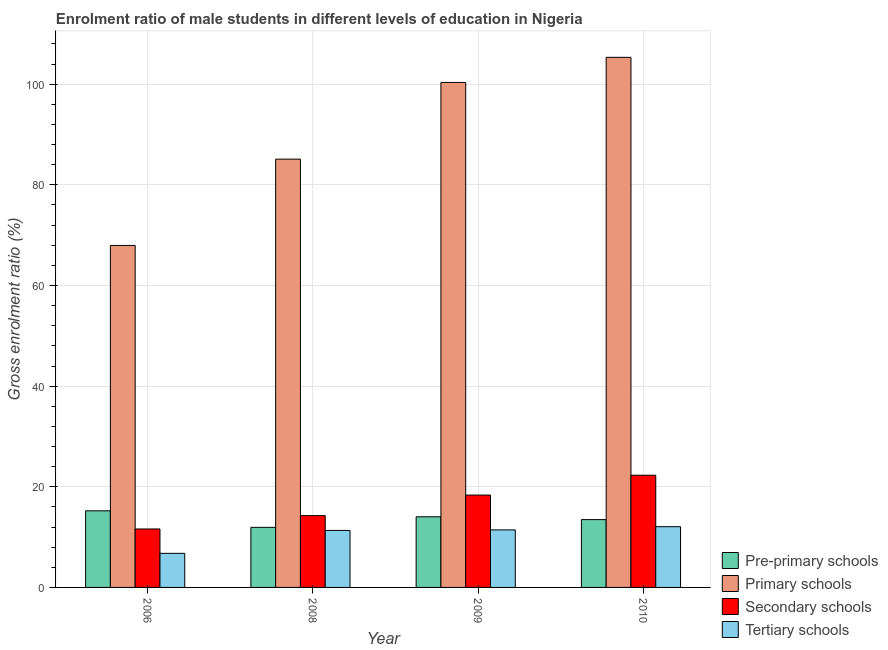How many different coloured bars are there?
Your response must be concise. 4. Are the number of bars on each tick of the X-axis equal?
Make the answer very short. Yes. How many bars are there on the 1st tick from the left?
Offer a terse response. 4. What is the gross enrolment ratio(female) in secondary schools in 2006?
Give a very brief answer. 11.61. Across all years, what is the maximum gross enrolment ratio(female) in primary schools?
Provide a short and direct response. 105.34. Across all years, what is the minimum gross enrolment ratio(female) in primary schools?
Keep it short and to the point. 67.96. In which year was the gross enrolment ratio(female) in tertiary schools minimum?
Give a very brief answer. 2006. What is the total gross enrolment ratio(female) in primary schools in the graph?
Give a very brief answer. 358.75. What is the difference between the gross enrolment ratio(female) in primary schools in 2008 and that in 2009?
Your response must be concise. -15.24. What is the difference between the gross enrolment ratio(female) in secondary schools in 2009 and the gross enrolment ratio(female) in tertiary schools in 2010?
Make the answer very short. -3.94. What is the average gross enrolment ratio(female) in primary schools per year?
Give a very brief answer. 89.69. In how many years, is the gross enrolment ratio(female) in pre-primary schools greater than 56 %?
Make the answer very short. 0. What is the ratio of the gross enrolment ratio(female) in tertiary schools in 2006 to that in 2008?
Provide a succinct answer. 0.6. Is the gross enrolment ratio(female) in tertiary schools in 2008 less than that in 2009?
Provide a short and direct response. Yes. What is the difference between the highest and the second highest gross enrolment ratio(female) in secondary schools?
Your answer should be compact. 3.94. What is the difference between the highest and the lowest gross enrolment ratio(female) in pre-primary schools?
Make the answer very short. 3.29. Is the sum of the gross enrolment ratio(female) in primary schools in 2009 and 2010 greater than the maximum gross enrolment ratio(female) in secondary schools across all years?
Offer a very short reply. Yes. Is it the case that in every year, the sum of the gross enrolment ratio(female) in pre-primary schools and gross enrolment ratio(female) in primary schools is greater than the sum of gross enrolment ratio(female) in secondary schools and gross enrolment ratio(female) in tertiary schools?
Provide a succinct answer. No. What does the 4th bar from the left in 2006 represents?
Provide a succinct answer. Tertiary schools. What does the 2nd bar from the right in 2010 represents?
Ensure brevity in your answer.  Secondary schools. Is it the case that in every year, the sum of the gross enrolment ratio(female) in pre-primary schools and gross enrolment ratio(female) in primary schools is greater than the gross enrolment ratio(female) in secondary schools?
Provide a short and direct response. Yes. Are all the bars in the graph horizontal?
Provide a succinct answer. No. Are the values on the major ticks of Y-axis written in scientific E-notation?
Your response must be concise. No. Does the graph contain any zero values?
Give a very brief answer. No. Where does the legend appear in the graph?
Give a very brief answer. Bottom right. How are the legend labels stacked?
Give a very brief answer. Vertical. What is the title of the graph?
Offer a terse response. Enrolment ratio of male students in different levels of education in Nigeria. Does "Natural Gas" appear as one of the legend labels in the graph?
Offer a very short reply. No. What is the label or title of the X-axis?
Provide a succinct answer. Year. What is the Gross enrolment ratio (%) of Pre-primary schools in 2006?
Make the answer very short. 15.23. What is the Gross enrolment ratio (%) of Primary schools in 2006?
Provide a short and direct response. 67.96. What is the Gross enrolment ratio (%) of Secondary schools in 2006?
Your answer should be very brief. 11.61. What is the Gross enrolment ratio (%) of Tertiary schools in 2006?
Keep it short and to the point. 6.78. What is the Gross enrolment ratio (%) of Pre-primary schools in 2008?
Make the answer very short. 11.94. What is the Gross enrolment ratio (%) in Primary schools in 2008?
Offer a very short reply. 85.11. What is the Gross enrolment ratio (%) in Secondary schools in 2008?
Ensure brevity in your answer.  14.27. What is the Gross enrolment ratio (%) of Tertiary schools in 2008?
Keep it short and to the point. 11.32. What is the Gross enrolment ratio (%) in Pre-primary schools in 2009?
Keep it short and to the point. 14.04. What is the Gross enrolment ratio (%) in Primary schools in 2009?
Your response must be concise. 100.35. What is the Gross enrolment ratio (%) of Secondary schools in 2009?
Your answer should be compact. 18.35. What is the Gross enrolment ratio (%) in Tertiary schools in 2009?
Offer a very short reply. 11.43. What is the Gross enrolment ratio (%) of Pre-primary schools in 2010?
Keep it short and to the point. 13.48. What is the Gross enrolment ratio (%) of Primary schools in 2010?
Give a very brief answer. 105.34. What is the Gross enrolment ratio (%) of Secondary schools in 2010?
Your response must be concise. 22.3. What is the Gross enrolment ratio (%) in Tertiary schools in 2010?
Provide a succinct answer. 12.07. Across all years, what is the maximum Gross enrolment ratio (%) of Pre-primary schools?
Offer a very short reply. 15.23. Across all years, what is the maximum Gross enrolment ratio (%) of Primary schools?
Offer a very short reply. 105.34. Across all years, what is the maximum Gross enrolment ratio (%) in Secondary schools?
Your answer should be compact. 22.3. Across all years, what is the maximum Gross enrolment ratio (%) in Tertiary schools?
Make the answer very short. 12.07. Across all years, what is the minimum Gross enrolment ratio (%) in Pre-primary schools?
Offer a terse response. 11.94. Across all years, what is the minimum Gross enrolment ratio (%) of Primary schools?
Your response must be concise. 67.96. Across all years, what is the minimum Gross enrolment ratio (%) in Secondary schools?
Give a very brief answer. 11.61. Across all years, what is the minimum Gross enrolment ratio (%) in Tertiary schools?
Give a very brief answer. 6.78. What is the total Gross enrolment ratio (%) in Pre-primary schools in the graph?
Make the answer very short. 54.68. What is the total Gross enrolment ratio (%) of Primary schools in the graph?
Offer a very short reply. 358.75. What is the total Gross enrolment ratio (%) of Secondary schools in the graph?
Give a very brief answer. 66.53. What is the total Gross enrolment ratio (%) of Tertiary schools in the graph?
Offer a terse response. 41.6. What is the difference between the Gross enrolment ratio (%) in Pre-primary schools in 2006 and that in 2008?
Your answer should be compact. 3.29. What is the difference between the Gross enrolment ratio (%) in Primary schools in 2006 and that in 2008?
Ensure brevity in your answer.  -17.15. What is the difference between the Gross enrolment ratio (%) in Secondary schools in 2006 and that in 2008?
Keep it short and to the point. -2.65. What is the difference between the Gross enrolment ratio (%) of Tertiary schools in 2006 and that in 2008?
Make the answer very short. -4.55. What is the difference between the Gross enrolment ratio (%) of Pre-primary schools in 2006 and that in 2009?
Your response must be concise. 1.19. What is the difference between the Gross enrolment ratio (%) of Primary schools in 2006 and that in 2009?
Ensure brevity in your answer.  -32.39. What is the difference between the Gross enrolment ratio (%) in Secondary schools in 2006 and that in 2009?
Provide a short and direct response. -6.74. What is the difference between the Gross enrolment ratio (%) of Tertiary schools in 2006 and that in 2009?
Provide a succinct answer. -4.66. What is the difference between the Gross enrolment ratio (%) of Pre-primary schools in 2006 and that in 2010?
Your answer should be compact. 1.75. What is the difference between the Gross enrolment ratio (%) in Primary schools in 2006 and that in 2010?
Your answer should be very brief. -37.38. What is the difference between the Gross enrolment ratio (%) in Secondary schools in 2006 and that in 2010?
Your answer should be compact. -10.68. What is the difference between the Gross enrolment ratio (%) in Tertiary schools in 2006 and that in 2010?
Your answer should be very brief. -5.29. What is the difference between the Gross enrolment ratio (%) of Pre-primary schools in 2008 and that in 2009?
Keep it short and to the point. -2.1. What is the difference between the Gross enrolment ratio (%) in Primary schools in 2008 and that in 2009?
Offer a very short reply. -15.24. What is the difference between the Gross enrolment ratio (%) of Secondary schools in 2008 and that in 2009?
Offer a very short reply. -4.09. What is the difference between the Gross enrolment ratio (%) of Tertiary schools in 2008 and that in 2009?
Ensure brevity in your answer.  -0.11. What is the difference between the Gross enrolment ratio (%) of Pre-primary schools in 2008 and that in 2010?
Your answer should be compact. -1.54. What is the difference between the Gross enrolment ratio (%) of Primary schools in 2008 and that in 2010?
Keep it short and to the point. -20.23. What is the difference between the Gross enrolment ratio (%) in Secondary schools in 2008 and that in 2010?
Give a very brief answer. -8.03. What is the difference between the Gross enrolment ratio (%) of Tertiary schools in 2008 and that in 2010?
Your answer should be compact. -0.75. What is the difference between the Gross enrolment ratio (%) in Pre-primary schools in 2009 and that in 2010?
Provide a succinct answer. 0.56. What is the difference between the Gross enrolment ratio (%) of Primary schools in 2009 and that in 2010?
Keep it short and to the point. -4.99. What is the difference between the Gross enrolment ratio (%) of Secondary schools in 2009 and that in 2010?
Ensure brevity in your answer.  -3.94. What is the difference between the Gross enrolment ratio (%) in Tertiary schools in 2009 and that in 2010?
Offer a very short reply. -0.64. What is the difference between the Gross enrolment ratio (%) of Pre-primary schools in 2006 and the Gross enrolment ratio (%) of Primary schools in 2008?
Offer a terse response. -69.88. What is the difference between the Gross enrolment ratio (%) of Pre-primary schools in 2006 and the Gross enrolment ratio (%) of Secondary schools in 2008?
Provide a short and direct response. 0.96. What is the difference between the Gross enrolment ratio (%) in Pre-primary schools in 2006 and the Gross enrolment ratio (%) in Tertiary schools in 2008?
Your response must be concise. 3.9. What is the difference between the Gross enrolment ratio (%) in Primary schools in 2006 and the Gross enrolment ratio (%) in Secondary schools in 2008?
Your answer should be very brief. 53.69. What is the difference between the Gross enrolment ratio (%) of Primary schools in 2006 and the Gross enrolment ratio (%) of Tertiary schools in 2008?
Your response must be concise. 56.64. What is the difference between the Gross enrolment ratio (%) of Secondary schools in 2006 and the Gross enrolment ratio (%) of Tertiary schools in 2008?
Keep it short and to the point. 0.29. What is the difference between the Gross enrolment ratio (%) of Pre-primary schools in 2006 and the Gross enrolment ratio (%) of Primary schools in 2009?
Your response must be concise. -85.12. What is the difference between the Gross enrolment ratio (%) of Pre-primary schools in 2006 and the Gross enrolment ratio (%) of Secondary schools in 2009?
Offer a terse response. -3.13. What is the difference between the Gross enrolment ratio (%) in Pre-primary schools in 2006 and the Gross enrolment ratio (%) in Tertiary schools in 2009?
Provide a short and direct response. 3.79. What is the difference between the Gross enrolment ratio (%) of Primary schools in 2006 and the Gross enrolment ratio (%) of Secondary schools in 2009?
Keep it short and to the point. 49.61. What is the difference between the Gross enrolment ratio (%) of Primary schools in 2006 and the Gross enrolment ratio (%) of Tertiary schools in 2009?
Ensure brevity in your answer.  56.53. What is the difference between the Gross enrolment ratio (%) in Secondary schools in 2006 and the Gross enrolment ratio (%) in Tertiary schools in 2009?
Your response must be concise. 0.18. What is the difference between the Gross enrolment ratio (%) of Pre-primary schools in 2006 and the Gross enrolment ratio (%) of Primary schools in 2010?
Ensure brevity in your answer.  -90.11. What is the difference between the Gross enrolment ratio (%) of Pre-primary schools in 2006 and the Gross enrolment ratio (%) of Secondary schools in 2010?
Your answer should be compact. -7.07. What is the difference between the Gross enrolment ratio (%) of Pre-primary schools in 2006 and the Gross enrolment ratio (%) of Tertiary schools in 2010?
Provide a short and direct response. 3.16. What is the difference between the Gross enrolment ratio (%) of Primary schools in 2006 and the Gross enrolment ratio (%) of Secondary schools in 2010?
Provide a short and direct response. 45.67. What is the difference between the Gross enrolment ratio (%) in Primary schools in 2006 and the Gross enrolment ratio (%) in Tertiary schools in 2010?
Your response must be concise. 55.89. What is the difference between the Gross enrolment ratio (%) of Secondary schools in 2006 and the Gross enrolment ratio (%) of Tertiary schools in 2010?
Provide a short and direct response. -0.46. What is the difference between the Gross enrolment ratio (%) of Pre-primary schools in 2008 and the Gross enrolment ratio (%) of Primary schools in 2009?
Provide a succinct answer. -88.41. What is the difference between the Gross enrolment ratio (%) of Pre-primary schools in 2008 and the Gross enrolment ratio (%) of Secondary schools in 2009?
Your answer should be compact. -6.42. What is the difference between the Gross enrolment ratio (%) of Pre-primary schools in 2008 and the Gross enrolment ratio (%) of Tertiary schools in 2009?
Keep it short and to the point. 0.5. What is the difference between the Gross enrolment ratio (%) of Primary schools in 2008 and the Gross enrolment ratio (%) of Secondary schools in 2009?
Your response must be concise. 66.75. What is the difference between the Gross enrolment ratio (%) in Primary schools in 2008 and the Gross enrolment ratio (%) in Tertiary schools in 2009?
Your answer should be compact. 73.67. What is the difference between the Gross enrolment ratio (%) in Secondary schools in 2008 and the Gross enrolment ratio (%) in Tertiary schools in 2009?
Provide a short and direct response. 2.83. What is the difference between the Gross enrolment ratio (%) of Pre-primary schools in 2008 and the Gross enrolment ratio (%) of Primary schools in 2010?
Your answer should be very brief. -93.4. What is the difference between the Gross enrolment ratio (%) of Pre-primary schools in 2008 and the Gross enrolment ratio (%) of Secondary schools in 2010?
Your answer should be very brief. -10.36. What is the difference between the Gross enrolment ratio (%) in Pre-primary schools in 2008 and the Gross enrolment ratio (%) in Tertiary schools in 2010?
Make the answer very short. -0.13. What is the difference between the Gross enrolment ratio (%) of Primary schools in 2008 and the Gross enrolment ratio (%) of Secondary schools in 2010?
Keep it short and to the point. 62.81. What is the difference between the Gross enrolment ratio (%) in Primary schools in 2008 and the Gross enrolment ratio (%) in Tertiary schools in 2010?
Offer a very short reply. 73.04. What is the difference between the Gross enrolment ratio (%) in Secondary schools in 2008 and the Gross enrolment ratio (%) in Tertiary schools in 2010?
Provide a succinct answer. 2.2. What is the difference between the Gross enrolment ratio (%) of Pre-primary schools in 2009 and the Gross enrolment ratio (%) of Primary schools in 2010?
Keep it short and to the point. -91.3. What is the difference between the Gross enrolment ratio (%) of Pre-primary schools in 2009 and the Gross enrolment ratio (%) of Secondary schools in 2010?
Make the answer very short. -8.26. What is the difference between the Gross enrolment ratio (%) of Pre-primary schools in 2009 and the Gross enrolment ratio (%) of Tertiary schools in 2010?
Ensure brevity in your answer.  1.97. What is the difference between the Gross enrolment ratio (%) in Primary schools in 2009 and the Gross enrolment ratio (%) in Secondary schools in 2010?
Make the answer very short. 78.05. What is the difference between the Gross enrolment ratio (%) of Primary schools in 2009 and the Gross enrolment ratio (%) of Tertiary schools in 2010?
Keep it short and to the point. 88.28. What is the difference between the Gross enrolment ratio (%) of Secondary schools in 2009 and the Gross enrolment ratio (%) of Tertiary schools in 2010?
Provide a short and direct response. 6.28. What is the average Gross enrolment ratio (%) of Pre-primary schools per year?
Provide a succinct answer. 13.67. What is the average Gross enrolment ratio (%) of Primary schools per year?
Provide a short and direct response. 89.69. What is the average Gross enrolment ratio (%) of Secondary schools per year?
Provide a short and direct response. 16.63. What is the average Gross enrolment ratio (%) in Tertiary schools per year?
Provide a short and direct response. 10.4. In the year 2006, what is the difference between the Gross enrolment ratio (%) of Pre-primary schools and Gross enrolment ratio (%) of Primary schools?
Keep it short and to the point. -52.73. In the year 2006, what is the difference between the Gross enrolment ratio (%) of Pre-primary schools and Gross enrolment ratio (%) of Secondary schools?
Offer a terse response. 3.61. In the year 2006, what is the difference between the Gross enrolment ratio (%) in Pre-primary schools and Gross enrolment ratio (%) in Tertiary schools?
Provide a succinct answer. 8.45. In the year 2006, what is the difference between the Gross enrolment ratio (%) of Primary schools and Gross enrolment ratio (%) of Secondary schools?
Make the answer very short. 56.35. In the year 2006, what is the difference between the Gross enrolment ratio (%) in Primary schools and Gross enrolment ratio (%) in Tertiary schools?
Keep it short and to the point. 61.19. In the year 2006, what is the difference between the Gross enrolment ratio (%) in Secondary schools and Gross enrolment ratio (%) in Tertiary schools?
Ensure brevity in your answer.  4.84. In the year 2008, what is the difference between the Gross enrolment ratio (%) in Pre-primary schools and Gross enrolment ratio (%) in Primary schools?
Keep it short and to the point. -73.17. In the year 2008, what is the difference between the Gross enrolment ratio (%) of Pre-primary schools and Gross enrolment ratio (%) of Secondary schools?
Keep it short and to the point. -2.33. In the year 2008, what is the difference between the Gross enrolment ratio (%) in Pre-primary schools and Gross enrolment ratio (%) in Tertiary schools?
Offer a terse response. 0.61. In the year 2008, what is the difference between the Gross enrolment ratio (%) of Primary schools and Gross enrolment ratio (%) of Secondary schools?
Give a very brief answer. 70.84. In the year 2008, what is the difference between the Gross enrolment ratio (%) of Primary schools and Gross enrolment ratio (%) of Tertiary schools?
Your answer should be very brief. 73.78. In the year 2008, what is the difference between the Gross enrolment ratio (%) in Secondary schools and Gross enrolment ratio (%) in Tertiary schools?
Offer a very short reply. 2.94. In the year 2009, what is the difference between the Gross enrolment ratio (%) in Pre-primary schools and Gross enrolment ratio (%) in Primary schools?
Offer a very short reply. -86.31. In the year 2009, what is the difference between the Gross enrolment ratio (%) in Pre-primary schools and Gross enrolment ratio (%) in Secondary schools?
Your response must be concise. -4.32. In the year 2009, what is the difference between the Gross enrolment ratio (%) in Pre-primary schools and Gross enrolment ratio (%) in Tertiary schools?
Your answer should be compact. 2.6. In the year 2009, what is the difference between the Gross enrolment ratio (%) of Primary schools and Gross enrolment ratio (%) of Secondary schools?
Keep it short and to the point. 82. In the year 2009, what is the difference between the Gross enrolment ratio (%) of Primary schools and Gross enrolment ratio (%) of Tertiary schools?
Offer a very short reply. 88.92. In the year 2009, what is the difference between the Gross enrolment ratio (%) in Secondary schools and Gross enrolment ratio (%) in Tertiary schools?
Offer a terse response. 6.92. In the year 2010, what is the difference between the Gross enrolment ratio (%) in Pre-primary schools and Gross enrolment ratio (%) in Primary schools?
Provide a short and direct response. -91.86. In the year 2010, what is the difference between the Gross enrolment ratio (%) of Pre-primary schools and Gross enrolment ratio (%) of Secondary schools?
Offer a terse response. -8.82. In the year 2010, what is the difference between the Gross enrolment ratio (%) of Pre-primary schools and Gross enrolment ratio (%) of Tertiary schools?
Provide a short and direct response. 1.41. In the year 2010, what is the difference between the Gross enrolment ratio (%) in Primary schools and Gross enrolment ratio (%) in Secondary schools?
Your answer should be very brief. 83.04. In the year 2010, what is the difference between the Gross enrolment ratio (%) in Primary schools and Gross enrolment ratio (%) in Tertiary schools?
Your answer should be very brief. 93.27. In the year 2010, what is the difference between the Gross enrolment ratio (%) in Secondary schools and Gross enrolment ratio (%) in Tertiary schools?
Give a very brief answer. 10.23. What is the ratio of the Gross enrolment ratio (%) of Pre-primary schools in 2006 to that in 2008?
Offer a terse response. 1.28. What is the ratio of the Gross enrolment ratio (%) in Primary schools in 2006 to that in 2008?
Provide a succinct answer. 0.8. What is the ratio of the Gross enrolment ratio (%) of Secondary schools in 2006 to that in 2008?
Offer a very short reply. 0.81. What is the ratio of the Gross enrolment ratio (%) in Tertiary schools in 2006 to that in 2008?
Your answer should be compact. 0.6. What is the ratio of the Gross enrolment ratio (%) of Pre-primary schools in 2006 to that in 2009?
Provide a short and direct response. 1.08. What is the ratio of the Gross enrolment ratio (%) of Primary schools in 2006 to that in 2009?
Offer a terse response. 0.68. What is the ratio of the Gross enrolment ratio (%) in Secondary schools in 2006 to that in 2009?
Give a very brief answer. 0.63. What is the ratio of the Gross enrolment ratio (%) of Tertiary schools in 2006 to that in 2009?
Provide a short and direct response. 0.59. What is the ratio of the Gross enrolment ratio (%) of Pre-primary schools in 2006 to that in 2010?
Provide a succinct answer. 1.13. What is the ratio of the Gross enrolment ratio (%) in Primary schools in 2006 to that in 2010?
Provide a succinct answer. 0.65. What is the ratio of the Gross enrolment ratio (%) in Secondary schools in 2006 to that in 2010?
Keep it short and to the point. 0.52. What is the ratio of the Gross enrolment ratio (%) of Tertiary schools in 2006 to that in 2010?
Your answer should be very brief. 0.56. What is the ratio of the Gross enrolment ratio (%) in Pre-primary schools in 2008 to that in 2009?
Give a very brief answer. 0.85. What is the ratio of the Gross enrolment ratio (%) of Primary schools in 2008 to that in 2009?
Give a very brief answer. 0.85. What is the ratio of the Gross enrolment ratio (%) of Secondary schools in 2008 to that in 2009?
Your answer should be very brief. 0.78. What is the ratio of the Gross enrolment ratio (%) of Tertiary schools in 2008 to that in 2009?
Your response must be concise. 0.99. What is the ratio of the Gross enrolment ratio (%) of Pre-primary schools in 2008 to that in 2010?
Offer a very short reply. 0.89. What is the ratio of the Gross enrolment ratio (%) of Primary schools in 2008 to that in 2010?
Give a very brief answer. 0.81. What is the ratio of the Gross enrolment ratio (%) in Secondary schools in 2008 to that in 2010?
Ensure brevity in your answer.  0.64. What is the ratio of the Gross enrolment ratio (%) in Tertiary schools in 2008 to that in 2010?
Your response must be concise. 0.94. What is the ratio of the Gross enrolment ratio (%) in Pre-primary schools in 2009 to that in 2010?
Your response must be concise. 1.04. What is the ratio of the Gross enrolment ratio (%) in Primary schools in 2009 to that in 2010?
Give a very brief answer. 0.95. What is the ratio of the Gross enrolment ratio (%) in Secondary schools in 2009 to that in 2010?
Ensure brevity in your answer.  0.82. What is the ratio of the Gross enrolment ratio (%) in Tertiary schools in 2009 to that in 2010?
Ensure brevity in your answer.  0.95. What is the difference between the highest and the second highest Gross enrolment ratio (%) of Pre-primary schools?
Ensure brevity in your answer.  1.19. What is the difference between the highest and the second highest Gross enrolment ratio (%) in Primary schools?
Your answer should be very brief. 4.99. What is the difference between the highest and the second highest Gross enrolment ratio (%) of Secondary schools?
Give a very brief answer. 3.94. What is the difference between the highest and the second highest Gross enrolment ratio (%) in Tertiary schools?
Offer a terse response. 0.64. What is the difference between the highest and the lowest Gross enrolment ratio (%) of Pre-primary schools?
Your answer should be very brief. 3.29. What is the difference between the highest and the lowest Gross enrolment ratio (%) in Primary schools?
Offer a very short reply. 37.38. What is the difference between the highest and the lowest Gross enrolment ratio (%) in Secondary schools?
Provide a succinct answer. 10.68. What is the difference between the highest and the lowest Gross enrolment ratio (%) in Tertiary schools?
Make the answer very short. 5.29. 